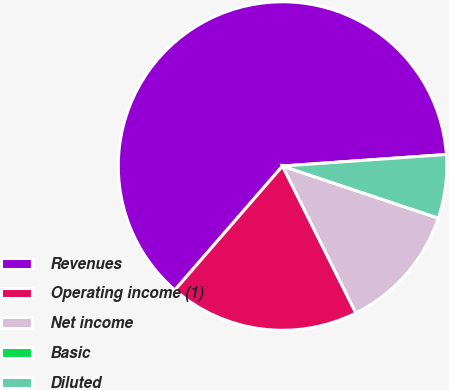<chart> <loc_0><loc_0><loc_500><loc_500><pie_chart><fcel>Revenues<fcel>Operating income (1)<fcel>Net income<fcel>Basic<fcel>Diluted<nl><fcel>62.5%<fcel>18.75%<fcel>12.5%<fcel>0.0%<fcel>6.25%<nl></chart> 